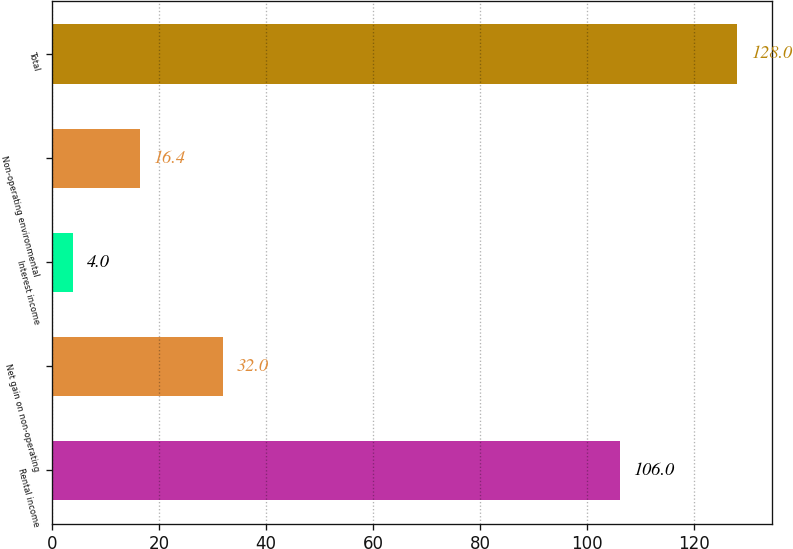Convert chart to OTSL. <chart><loc_0><loc_0><loc_500><loc_500><bar_chart><fcel>Rental income<fcel>Net gain on non-operating<fcel>Interest income<fcel>Non-operating environmental<fcel>Total<nl><fcel>106<fcel>32<fcel>4<fcel>16.4<fcel>128<nl></chart> 